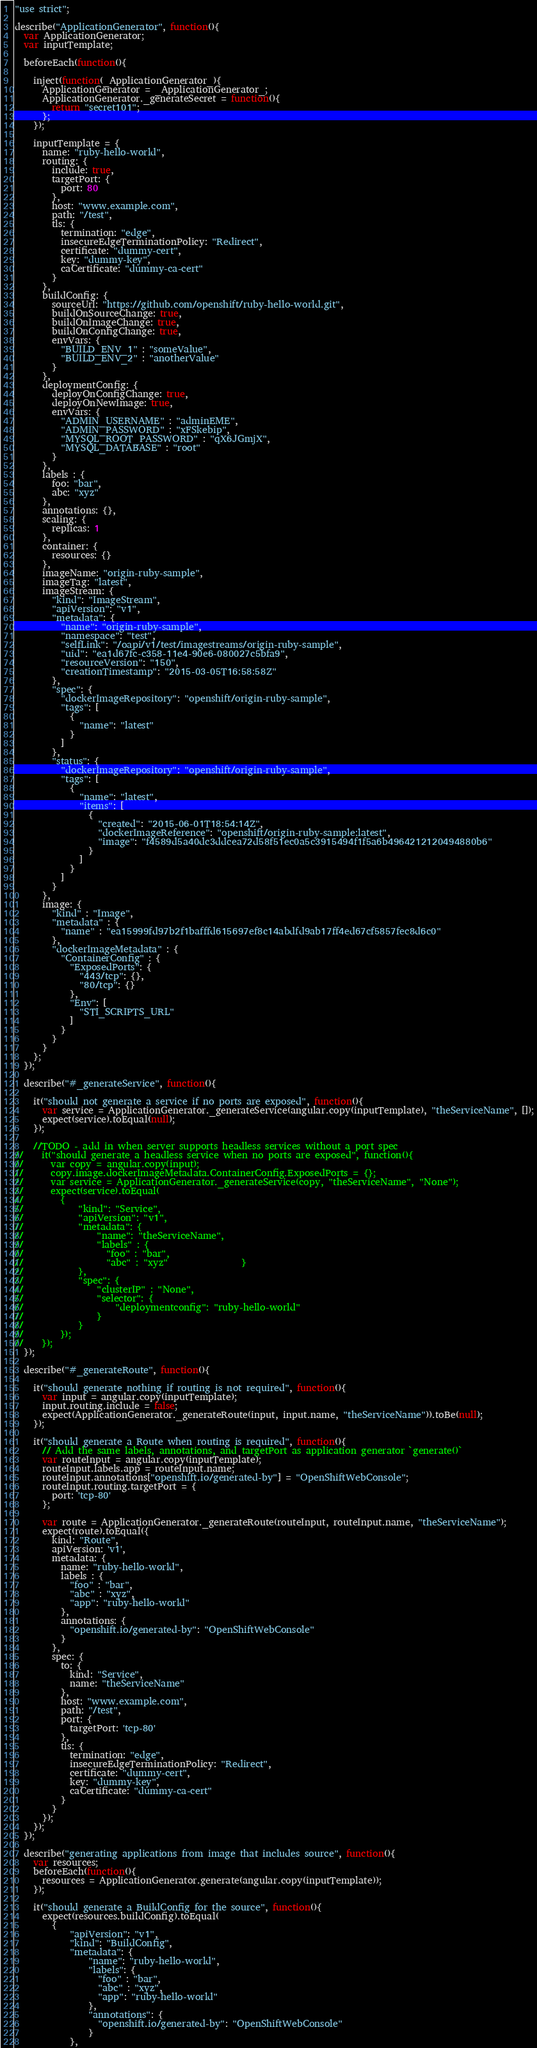<code> <loc_0><loc_0><loc_500><loc_500><_JavaScript_>"use strict";

describe("ApplicationGenerator", function(){
  var ApplicationGenerator;
  var inputTemplate;

  beforeEach(function(){

    inject(function(_ApplicationGenerator_){
      ApplicationGenerator = _ApplicationGenerator_;
      ApplicationGenerator._generateSecret = function(){
        return "secret101";
      };
    });

    inputTemplate = {
      name: "ruby-hello-world",
      routing: {
        include: true,
        targetPort: {
          port: 80
        },
        host: "www.example.com",
        path: "/test",
        tls: {
          termination: "edge",
          insecureEdgeTerminationPolicy: "Redirect",
          certificate: "dummy-cert",
          key: "dummy-key",
          caCertificate: "dummy-ca-cert"
        }
      },
      buildConfig: {
        sourceUrl: "https://github.com/openshift/ruby-hello-world.git",
        buildOnSourceChange: true,
        buildOnImageChange: true,
        buildOnConfigChange: true,
        envVars: {
          "BUILD_ENV_1" : "someValue",
          "BUILD_ENV_2" : "anotherValue"
        }
      },
      deploymentConfig: {
        deployOnConfigChange: true,
        deployOnNewImage: true,
        envVars: {
          "ADMIN_USERNAME" : "adminEME",
          "ADMIN_PASSWORD" : "xFSkebip",
          "MYSQL_ROOT_PASSWORD" : "qX6JGmjX",
          "MYSQL_DATABASE" : "root"
        }
      },
      labels : {
        foo: "bar",
        abc: "xyz"
      },
      annotations: {},
      scaling: {
        replicas: 1
      },
      container: {
        resources: {}
      },
      imageName: "origin-ruby-sample",
      imageTag: "latest",
      imageStream: {
        "kind": "ImageStream",
        "apiVersion": "v1",
        "metadata": {
          "name": "origin-ruby-sample",
          "namespace": "test",
          "selfLink": "/oapi/v1/test/imagestreams/origin-ruby-sample",
          "uid": "ea1d67fc-c358-11e4-90e6-080027c5bfa9",
          "resourceVersion": "150",
          "creationTimestamp": "2015-03-05T16:58:58Z"
        },
        "spec": {
          "dockerImageRepository": "openshift/origin-ruby-sample",
          "tags": [
            {
              "name": "latest"
            }
          ]
        },
        "status": {
          "dockerImageRepository": "openshift/origin-ruby-sample",
          "tags": [
            {
              "name": "latest",
              "items": [
                {
                  "created": "2015-06-01T18:54:14Z",
                  "dockerImageReference": "openshift/origin-ruby-sample:latest",
                  "image": "f4589d5a40dc3ddcea72d58f51ec0a5c3915494f1f5a6b4964212120494880b6"
                }
              ]
            }
          ]
        }
      },
      image: {
        "kind" : "Image",
        "metadata" : {
          "name" : "ea15999fd97b2f1bafffd615697ef8c14abdfd9ab17ff4ed67cf5857fec8d6c0"
        },
        "dockerImageMetadata" : {
          "ContainerConfig" : {
            "ExposedPorts": {
              "443/tcp": {},
              "80/tcp": {}
            },
            "Env": [
              "STI_SCRIPTS_URL"
            ]
          }
        }
      }
    };
  });

  describe("#_generateService", function(){

    it("should not generate a service if no ports are exposed", function(){
      var service = ApplicationGenerator._generateService(angular.copy(inputTemplate), "theServiceName", []);
      expect(service).toEqual(null);
    });

    //TODO - add in when server supports headless services without a port spec
//    it("should generate a headless service when no ports are exposed", function(){
//      var copy = angular.copy(input);
//      copy.image.dockerImageMetadata.ContainerConfig.ExposedPorts = {};
//      var service = ApplicationGenerator._generateService(copy, "theServiceName", "None");
//      expect(service).toEqual(
//        {
//            "kind": "Service",
//            "apiVersion": "v1",
//            "metadata": {
//                "name": "theServiceName",
//                "labels" : {
//                  "foo" : "bar",
//                  "abc" : "xyz"                }
//            },
//            "spec": {
//                "clusterIP" : "None",
//                "selector": {
//                    "deploymentconfig": "ruby-hello-world"
//                }
//            }
//        });
//    });
  });

  describe("#_generateRoute", function(){

    it("should generate nothing if routing is not required", function(){
      var input = angular.copy(inputTemplate);
      input.routing.include = false;
      expect(ApplicationGenerator._generateRoute(input, input.name, "theServiceName")).toBe(null);
    });

    it("should generate a Route when routing is required", function(){
      // Add the same labels, annotations, and targetPort as application generator `generate()`
      var routeInput = angular.copy(inputTemplate);
      routeInput.labels.app = routeInput.name;
      routeInput.annotations["openshift.io/generated-by"] = "OpenShiftWebConsole";
      routeInput.routing.targetPort = {
        port: 'tcp-80'
      };

      var route = ApplicationGenerator._generateRoute(routeInput, routeInput.name, "theServiceName");
      expect(route).toEqual({
        kind: "Route",
        apiVersion: 'v1',
        metadata: {
          name: "ruby-hello-world",
          labels : {
            "foo" : "bar",
            "abc" : "xyz",
            "app": "ruby-hello-world"
          },
          annotations: {
            "openshift.io/generated-by": "OpenShiftWebConsole"
          }
        },
        spec: {
          to: {
            kind: "Service",
            name: "theServiceName"
          },
          host: "www.example.com",
          path: "/test",
          port: {
            targetPort: 'tcp-80'
          },
          tls: {
            termination: "edge",
            insecureEdgeTerminationPolicy: "Redirect",
            certificate: "dummy-cert",
            key: "dummy-key",
            caCertificate: "dummy-ca-cert"
          }
        }
      });
    });
  });

  describe("generating applications from image that includes source", function(){
    var resources;
    beforeEach(function(){
      resources = ApplicationGenerator.generate(angular.copy(inputTemplate));
    });

    it("should generate a BuildConfig for the source", function(){
      expect(resources.buildConfig).toEqual(
        {
            "apiVersion": "v1",
            "kind": "BuildConfig",
            "metadata": {
                "name": "ruby-hello-world",
                "labels": {
                  "foo" : "bar",
                  "abc" : "xyz",
                  "app": "ruby-hello-world"
                },
                "annotations": {
                  "openshift.io/generated-by": "OpenShiftWebConsole"
                }
            },</code> 